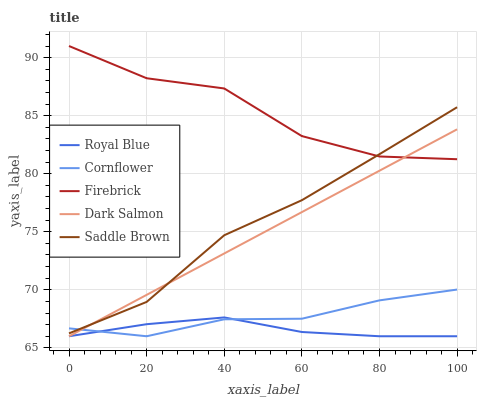Does Royal Blue have the minimum area under the curve?
Answer yes or no. Yes. Does Firebrick have the maximum area under the curve?
Answer yes or no. Yes. Does Firebrick have the minimum area under the curve?
Answer yes or no. No. Does Royal Blue have the maximum area under the curve?
Answer yes or no. No. Is Dark Salmon the smoothest?
Answer yes or no. Yes. Is Firebrick the roughest?
Answer yes or no. Yes. Is Royal Blue the smoothest?
Answer yes or no. No. Is Royal Blue the roughest?
Answer yes or no. No. Does Royal Blue have the lowest value?
Answer yes or no. Yes. Does Firebrick have the lowest value?
Answer yes or no. No. Does Firebrick have the highest value?
Answer yes or no. Yes. Does Royal Blue have the highest value?
Answer yes or no. No. Is Royal Blue less than Firebrick?
Answer yes or no. Yes. Is Firebrick greater than Royal Blue?
Answer yes or no. Yes. Does Cornflower intersect Saddle Brown?
Answer yes or no. Yes. Is Cornflower less than Saddle Brown?
Answer yes or no. No. Is Cornflower greater than Saddle Brown?
Answer yes or no. No. Does Royal Blue intersect Firebrick?
Answer yes or no. No. 